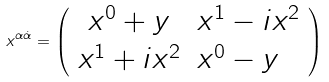Convert formula to latex. <formula><loc_0><loc_0><loc_500><loc_500>x ^ { \alpha { \dot { \alpha } } } = \left ( \begin{array} { c l } x ^ { 0 } + y & x ^ { 1 } - i x ^ { 2 } \\ x ^ { 1 } + i x ^ { 2 } & x ^ { 0 } - y \end{array} \right )</formula> 